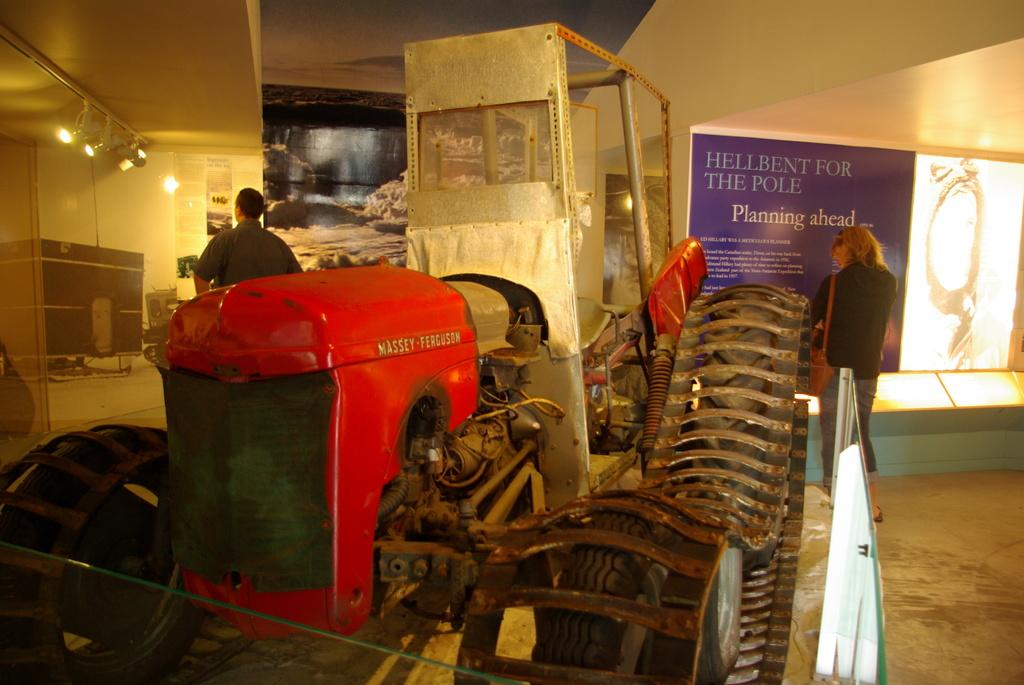What is the main setting of the image? The image is of a room. What can be seen in the foreground of the room? There is a vehicle in the foreground of the room. How many people are in the room? There are two persons standing at the back of the room. What is on the walls of the room? There are posters on the walls of the room. What is visible at the top of the room? There are lights visible at the top of the room. What type of bridge can be seen in the image? There is no bridge present in the image; it is a room with a vehicle, two persons, posters, and lights. How does the woman in the image contribute to the knowledge of the room? There is no woman present in the image, so it is not possible to determine her contribution to the knowledge of the room. 